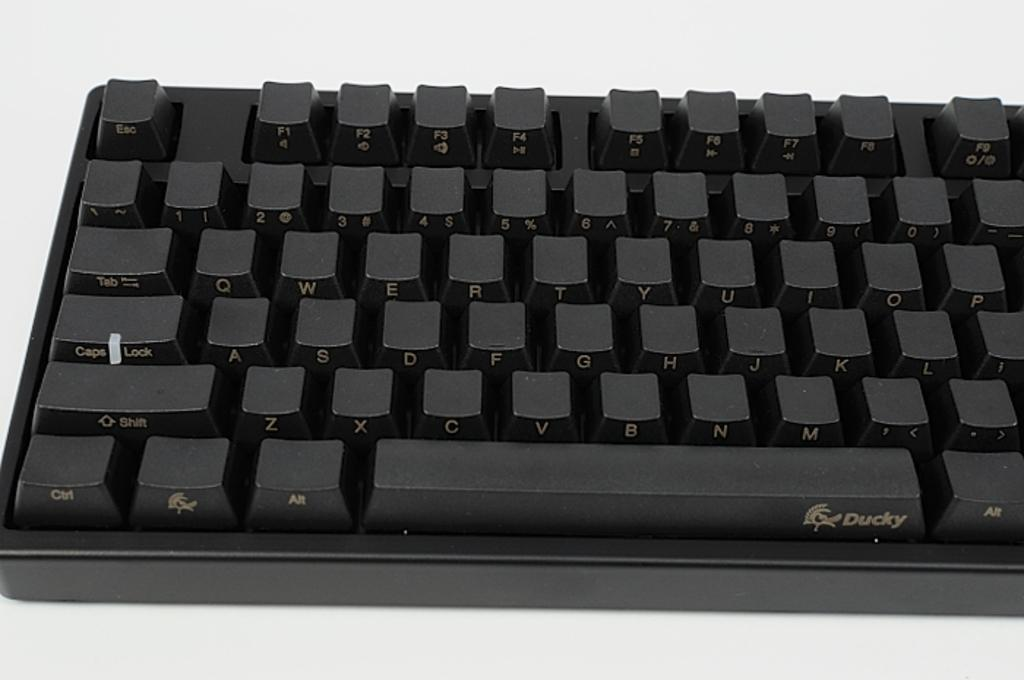<image>
Describe the image concisely. A small keyboard is labeled with a Ducky logo. 